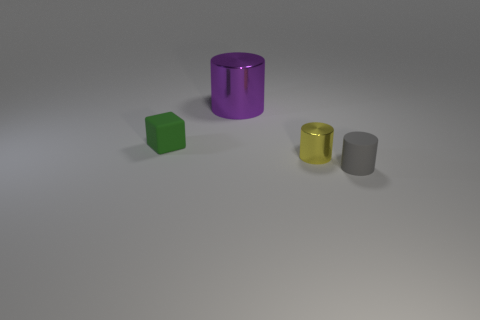Is the number of cylinders less than the number of things?
Provide a short and direct response. Yes. There is a tiny matte object that is the same shape as the purple metal object; what is its color?
Your response must be concise. Gray. Is there a large purple shiny thing that is to the left of the matte thing in front of the tiny thing that is to the left of the purple cylinder?
Offer a terse response. Yes. Do the tiny gray matte thing and the tiny yellow thing have the same shape?
Your response must be concise. Yes. Are there fewer purple shiny objects that are in front of the small gray matte cylinder than big metallic cylinders?
Ensure brevity in your answer.  Yes. What color is the matte thing that is right of the small rubber object to the left of the object to the right of the yellow metal object?
Ensure brevity in your answer.  Gray. What number of metallic things are big blue objects or large cylinders?
Keep it short and to the point. 1. Does the matte cube have the same size as the yellow shiny object?
Make the answer very short. Yes. Is the number of small green blocks in front of the rubber cube less than the number of cylinders right of the purple metal object?
Keep it short and to the point. Yes. Are there any other things that are the same size as the purple thing?
Provide a succinct answer. No. 